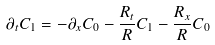Convert formula to latex. <formula><loc_0><loc_0><loc_500><loc_500>\partial _ { t } C _ { 1 } = - \partial _ { x } C _ { 0 } - \frac { R _ { t } } { R } C _ { 1 } - \frac { R _ { x } } { R } C _ { 0 }</formula> 